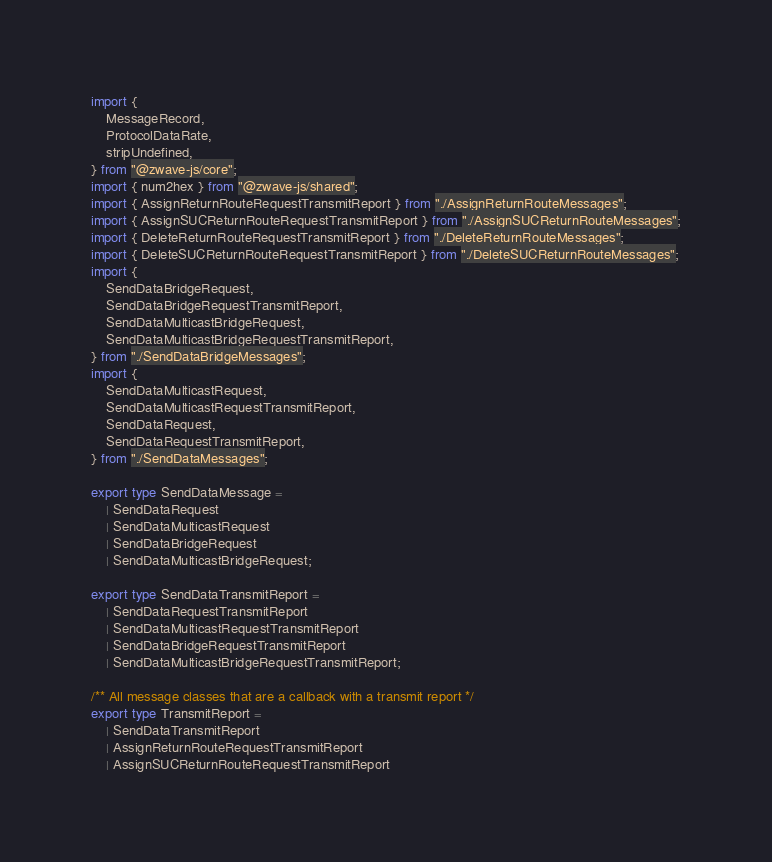<code> <loc_0><loc_0><loc_500><loc_500><_TypeScript_>import {
	MessageRecord,
	ProtocolDataRate,
	stripUndefined,
} from "@zwave-js/core";
import { num2hex } from "@zwave-js/shared";
import { AssignReturnRouteRequestTransmitReport } from "./AssignReturnRouteMessages";
import { AssignSUCReturnRouteRequestTransmitReport } from "./AssignSUCReturnRouteMessages";
import { DeleteReturnRouteRequestTransmitReport } from "./DeleteReturnRouteMessages";
import { DeleteSUCReturnRouteRequestTransmitReport } from "./DeleteSUCReturnRouteMessages";
import {
	SendDataBridgeRequest,
	SendDataBridgeRequestTransmitReport,
	SendDataMulticastBridgeRequest,
	SendDataMulticastBridgeRequestTransmitReport,
} from "./SendDataBridgeMessages";
import {
	SendDataMulticastRequest,
	SendDataMulticastRequestTransmitReport,
	SendDataRequest,
	SendDataRequestTransmitReport,
} from "./SendDataMessages";

export type SendDataMessage =
	| SendDataRequest
	| SendDataMulticastRequest
	| SendDataBridgeRequest
	| SendDataMulticastBridgeRequest;

export type SendDataTransmitReport =
	| SendDataRequestTransmitReport
	| SendDataMulticastRequestTransmitReport
	| SendDataBridgeRequestTransmitReport
	| SendDataMulticastBridgeRequestTransmitReport;

/** All message classes that are a callback with a transmit report */
export type TransmitReport =
	| SendDataTransmitReport
	| AssignReturnRouteRequestTransmitReport
	| AssignSUCReturnRouteRequestTransmitReport</code> 